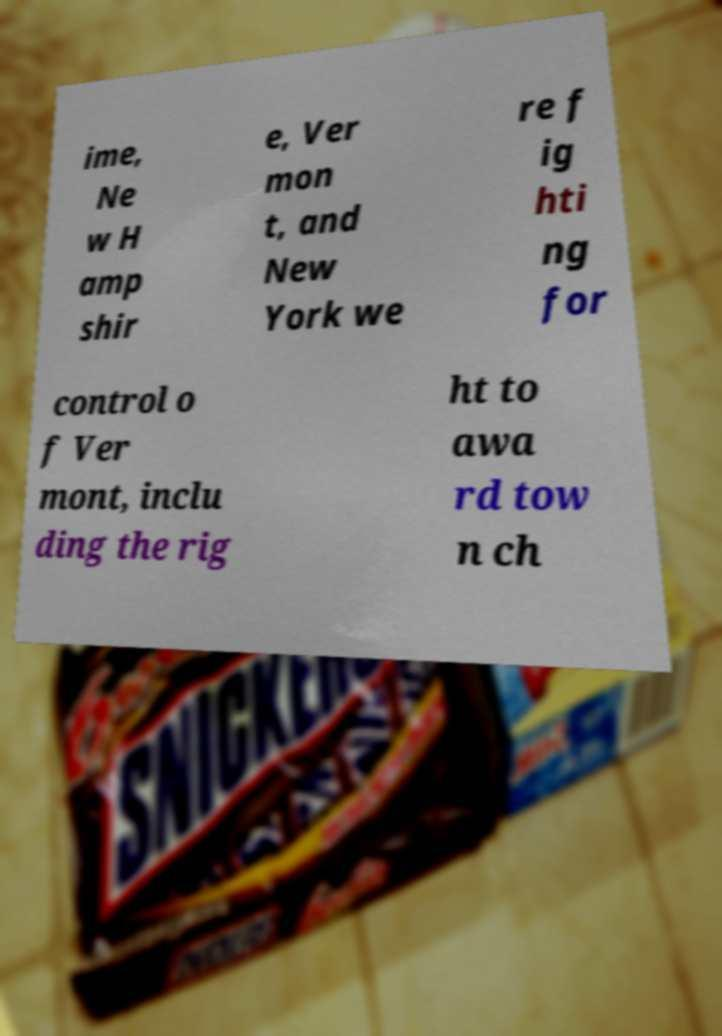Could you assist in decoding the text presented in this image and type it out clearly? ime, Ne w H amp shir e, Ver mon t, and New York we re f ig hti ng for control o f Ver mont, inclu ding the rig ht to awa rd tow n ch 